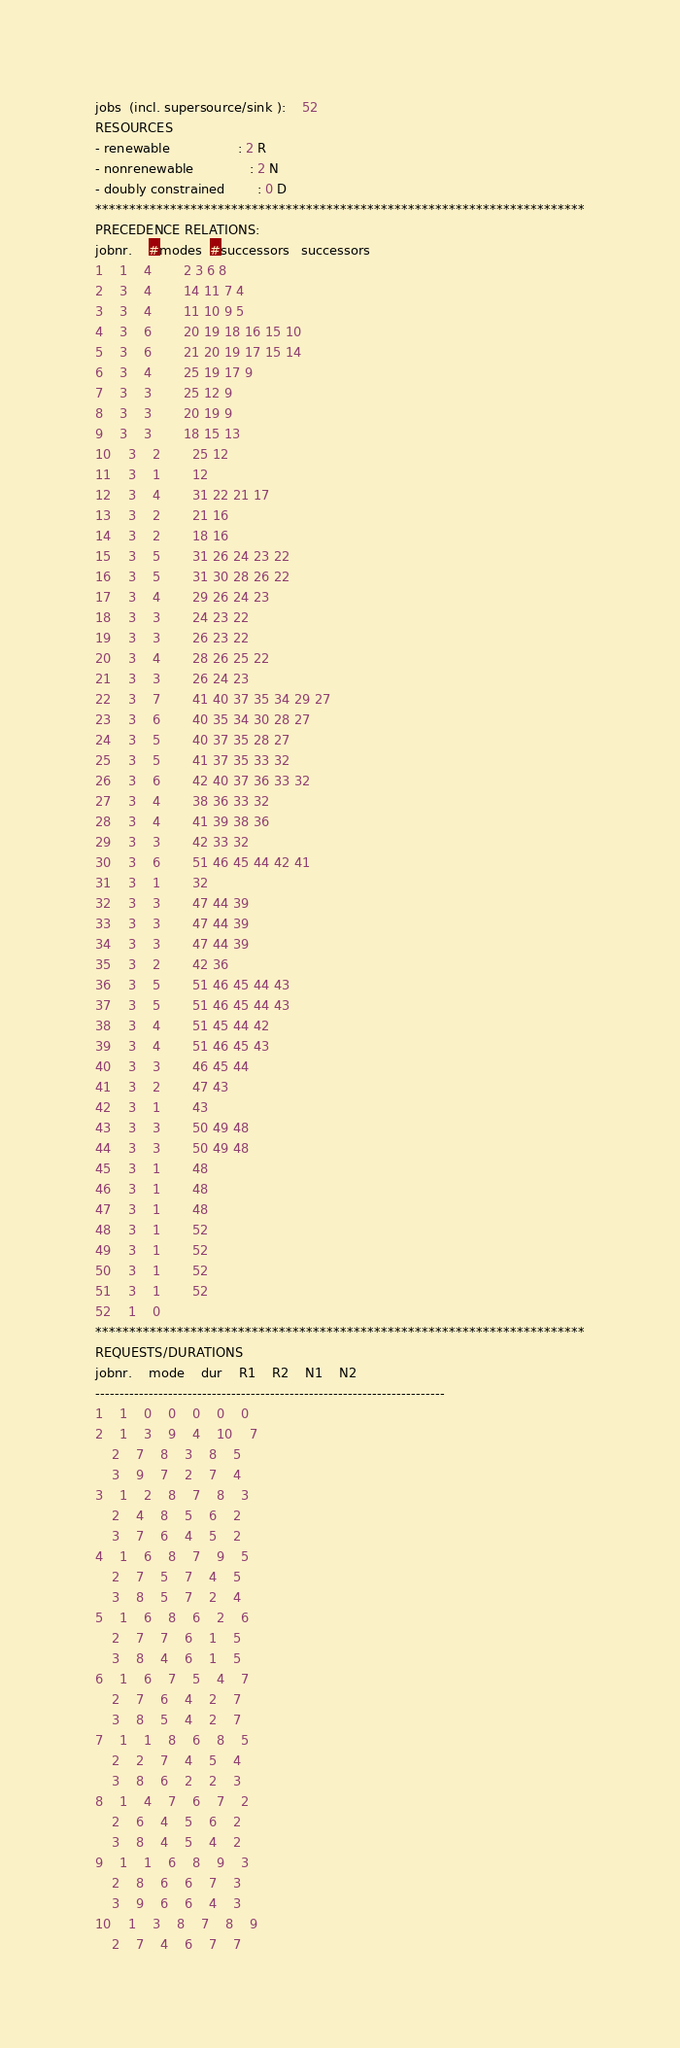<code> <loc_0><loc_0><loc_500><loc_500><_ObjectiveC_>jobs  (incl. supersource/sink ):	52
RESOURCES
- renewable                 : 2 R
- nonrenewable              : 2 N
- doubly constrained        : 0 D
************************************************************************
PRECEDENCE RELATIONS:
jobnr.    #modes  #successors   successors
1	1	4		2 3 6 8 
2	3	4		14 11 7 4 
3	3	4		11 10 9 5 
4	3	6		20 19 18 16 15 10 
5	3	6		21 20 19 17 15 14 
6	3	4		25 19 17 9 
7	3	3		25 12 9 
8	3	3		20 19 9 
9	3	3		18 15 13 
10	3	2		25 12 
11	3	1		12 
12	3	4		31 22 21 17 
13	3	2		21 16 
14	3	2		18 16 
15	3	5		31 26 24 23 22 
16	3	5		31 30 28 26 22 
17	3	4		29 26 24 23 
18	3	3		24 23 22 
19	3	3		26 23 22 
20	3	4		28 26 25 22 
21	3	3		26 24 23 
22	3	7		41 40 37 35 34 29 27 
23	3	6		40 35 34 30 28 27 
24	3	5		40 37 35 28 27 
25	3	5		41 37 35 33 32 
26	3	6		42 40 37 36 33 32 
27	3	4		38 36 33 32 
28	3	4		41 39 38 36 
29	3	3		42 33 32 
30	3	6		51 46 45 44 42 41 
31	3	1		32 
32	3	3		47 44 39 
33	3	3		47 44 39 
34	3	3		47 44 39 
35	3	2		42 36 
36	3	5		51 46 45 44 43 
37	3	5		51 46 45 44 43 
38	3	4		51 45 44 42 
39	3	4		51 46 45 43 
40	3	3		46 45 44 
41	3	2		47 43 
42	3	1		43 
43	3	3		50 49 48 
44	3	3		50 49 48 
45	3	1		48 
46	3	1		48 
47	3	1		48 
48	3	1		52 
49	3	1		52 
50	3	1		52 
51	3	1		52 
52	1	0		
************************************************************************
REQUESTS/DURATIONS
jobnr.	mode	dur	R1	R2	N1	N2	
------------------------------------------------------------------------
1	1	0	0	0	0	0	
2	1	3	9	4	10	7	
	2	7	8	3	8	5	
	3	9	7	2	7	4	
3	1	2	8	7	8	3	
	2	4	8	5	6	2	
	3	7	6	4	5	2	
4	1	6	8	7	9	5	
	2	7	5	7	4	5	
	3	8	5	7	2	4	
5	1	6	8	6	2	6	
	2	7	7	6	1	5	
	3	8	4	6	1	5	
6	1	6	7	5	4	7	
	2	7	6	4	2	7	
	3	8	5	4	2	7	
7	1	1	8	6	8	5	
	2	2	7	4	5	4	
	3	8	6	2	2	3	
8	1	4	7	6	7	2	
	2	6	4	5	6	2	
	3	8	4	5	4	2	
9	1	1	6	8	9	3	
	2	8	6	6	7	3	
	3	9	6	6	4	3	
10	1	3	8	7	8	9	
	2	7	4	6	7	7	</code> 